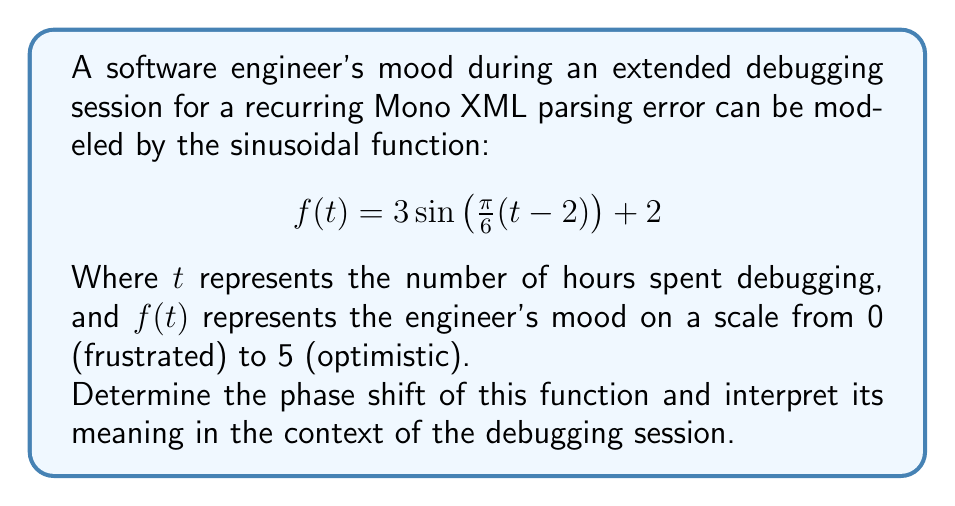Can you answer this question? To analyze the phase shift in this sinusoidal function, we need to compare it to the standard form of a sine function:

$$f(t) = A\sin(B(t-C)) + D$$

Where:
- $A$ is the amplitude
- $B$ is the frequency
- $C$ is the phase shift
- $D$ is the vertical shift

In our given function:

$$f(t) = 3\sin\left(\frac{\pi}{6}(t-2)\right) + 2$$

We can identify that:
- $A = 3$ (amplitude)
- $B = \frac{\pi}{6}$ (frequency)
- $C = 2$ (phase shift)
- $D = 2$ (vertical shift)

The phase shift is represented by $C$, which in this case is 2.

In the context of a sine function, a positive phase shift moves the graph to the right. This means that the function's cycle starts 2 units (hours) later than a standard sine function.

Interpreting this in the context of the debugging session:
1. The engineer's mood fluctuates sinusoidally over time.
2. The phase shift of 2 hours indicates that the engineer's mood cycle is delayed by 2 hours from the start of the debugging session.
3. This could represent an initial period of neutral or steady mood before the cyclical frustration and optimism set in.
4. The engineer might experience their first mood peak (most optimistic point) 2 hours later than they would without this phase shift.

This phase shift could be attributed to factors such as the initial focus and determination at the start of debugging, or the time it takes for the repetitive nature of the error to affect the engineer's mood.
Answer: The phase shift is 2 hours, indicating that the engineer's mood cycle is delayed by 2 hours from the start of the debugging session. 